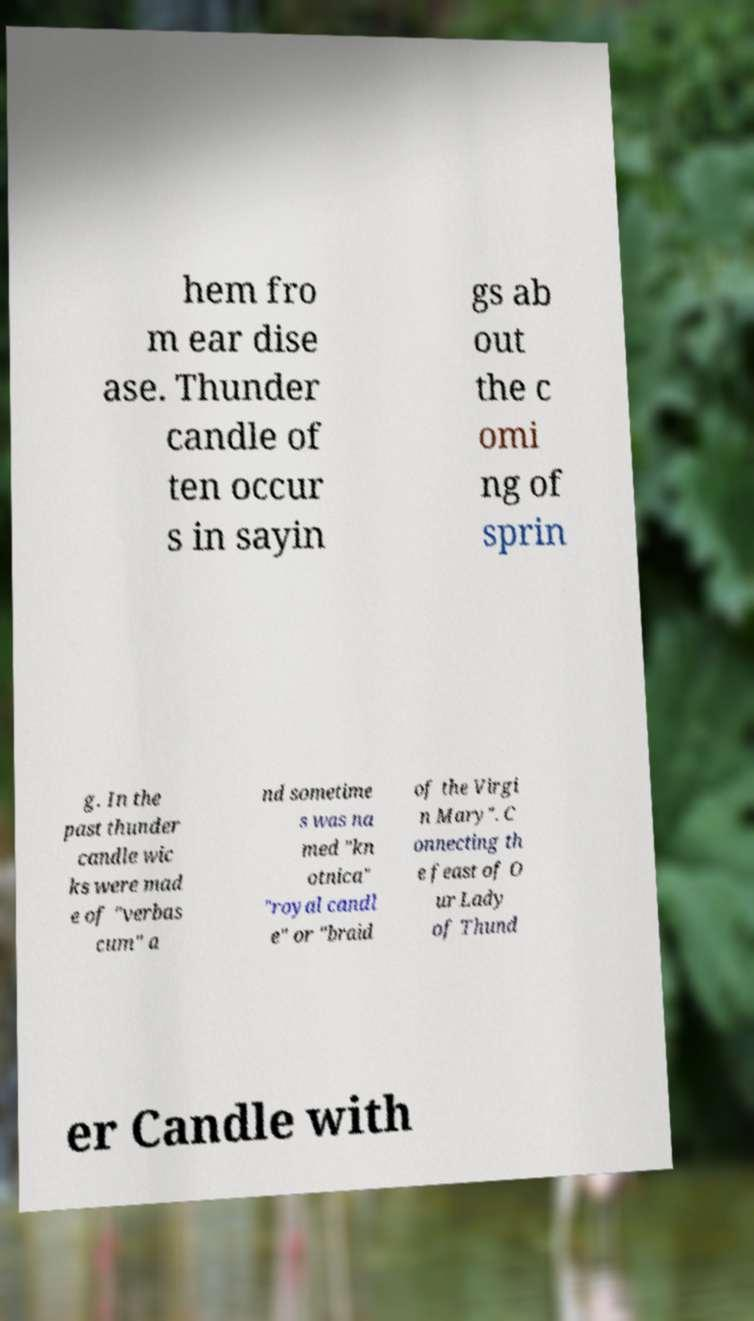I need the written content from this picture converted into text. Can you do that? hem fro m ear dise ase. Thunder candle of ten occur s in sayin gs ab out the c omi ng of sprin g. In the past thunder candle wic ks were mad e of "verbas cum" a nd sometime s was na med "kn otnica" "royal candl e" or "braid of the Virgi n Mary". C onnecting th e feast of O ur Lady of Thund er Candle with 